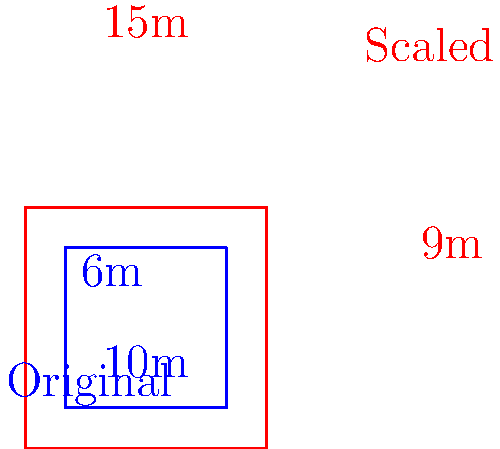A farmer wants to expand their barn and has asked you to help calculate the new dimensions for tax purposes. The original barn floor plan is a rectangle measuring 10m by 6m. If the farmer wants to scale up the barn by a factor of 1.5, what will be the area of the new barn floor plan? To solve this problem, we'll follow these steps:

1. Identify the original dimensions:
   Length = 10m
   Width = 6m

2. Calculate the original area:
   Original Area = Length × Width
   Original Area = 10m × 6m = 60m²

3. Apply the scale factor to the dimensions:
   New Length = Original Length × Scale Factor
   New Length = 10m × 1.5 = 15m

   New Width = Original Width × Scale Factor
   New Width = 6m × 1.5 = 9m

4. Calculate the new area:
   New Area = New Length × New Width
   New Area = 15m × 9m = 135m²

5. Verify using the scale factor squared:
   New Area = Original Area × (Scale Factor)²
   New Area = 60m² × (1.5)² = 60m² × 2.25 = 135m²

Therefore, the area of the new barn floor plan is 135m².
Answer: 135m² 